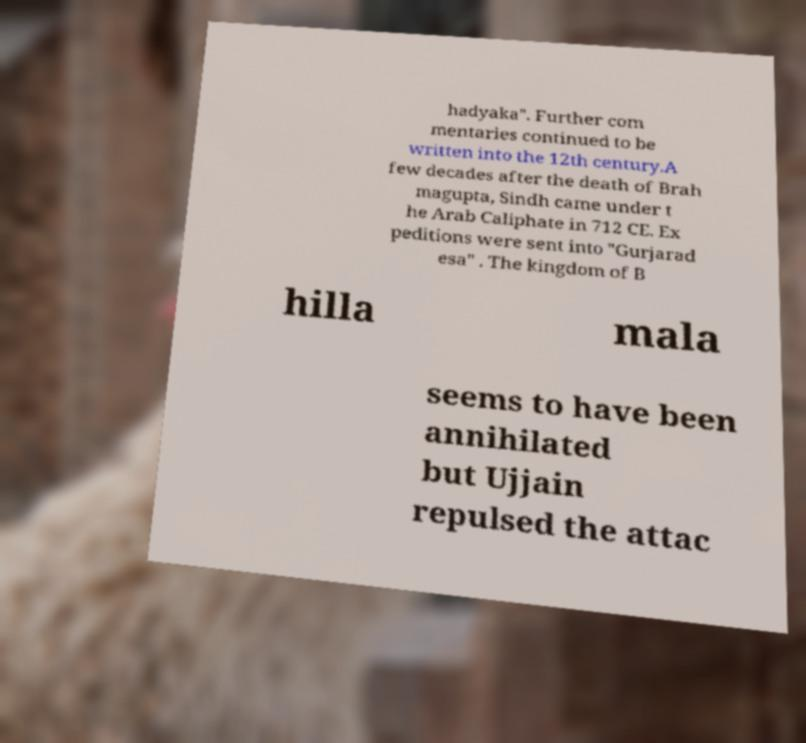Could you assist in decoding the text presented in this image and type it out clearly? hadyaka". Further com mentaries continued to be written into the 12th century.A few decades after the death of Brah magupta, Sindh came under t he Arab Caliphate in 712 CE. Ex peditions were sent into "Gurjarad esa" . The kingdom of B hilla mala seems to have been annihilated but Ujjain repulsed the attac 